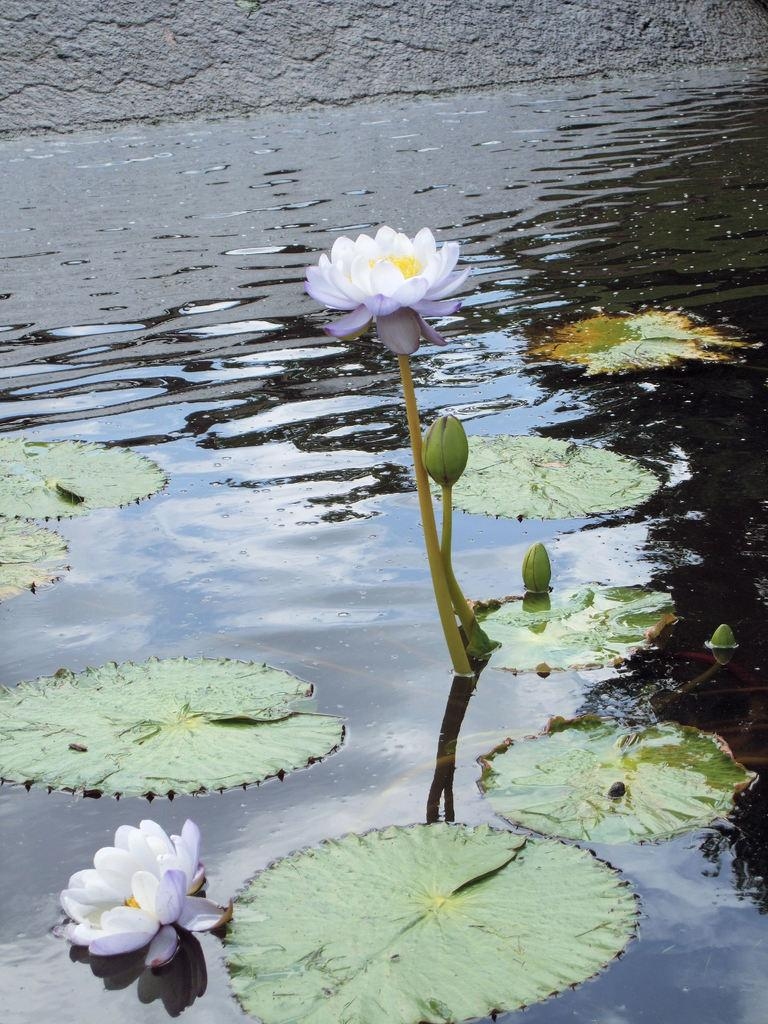What is in the water in the image? There are flowers in the water in the image. What else can be seen floating on the water? Leaves are floating on the water. What color are the flowers in the image? The flowers are white in color. Can you see a boot lying on the seashore in the image? There is no mention of a seashore or a boot in the image; it features flowers and leaves in the water. 